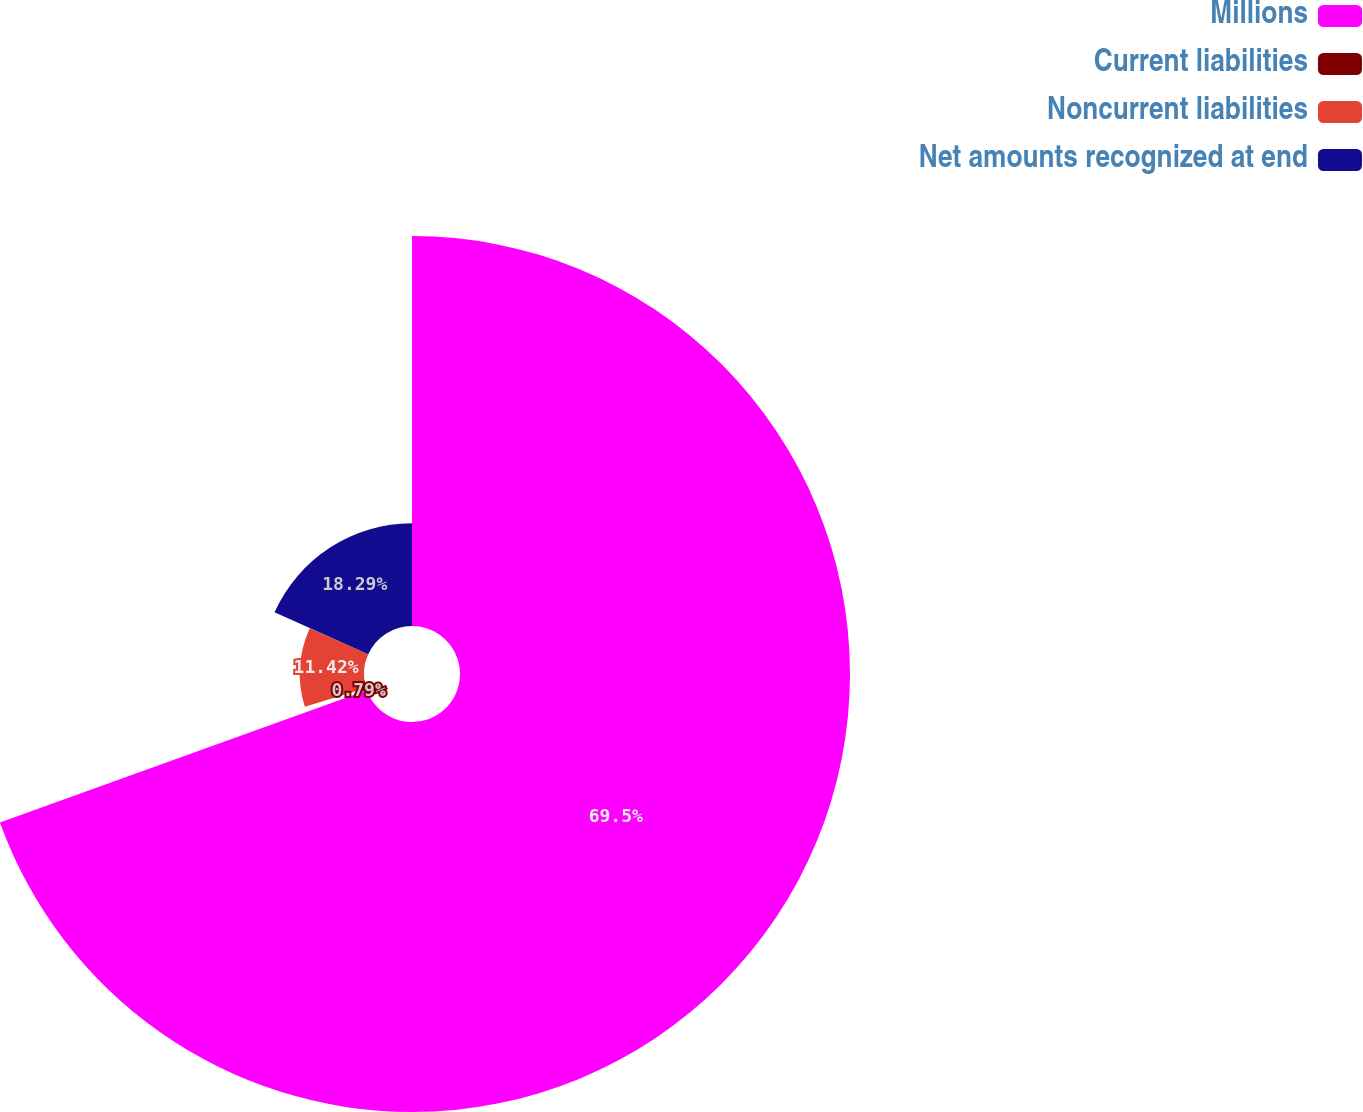<chart> <loc_0><loc_0><loc_500><loc_500><pie_chart><fcel>Millions<fcel>Current liabilities<fcel>Noncurrent liabilities<fcel>Net amounts recognized at end<nl><fcel>69.49%<fcel>0.79%<fcel>11.42%<fcel>18.29%<nl></chart> 